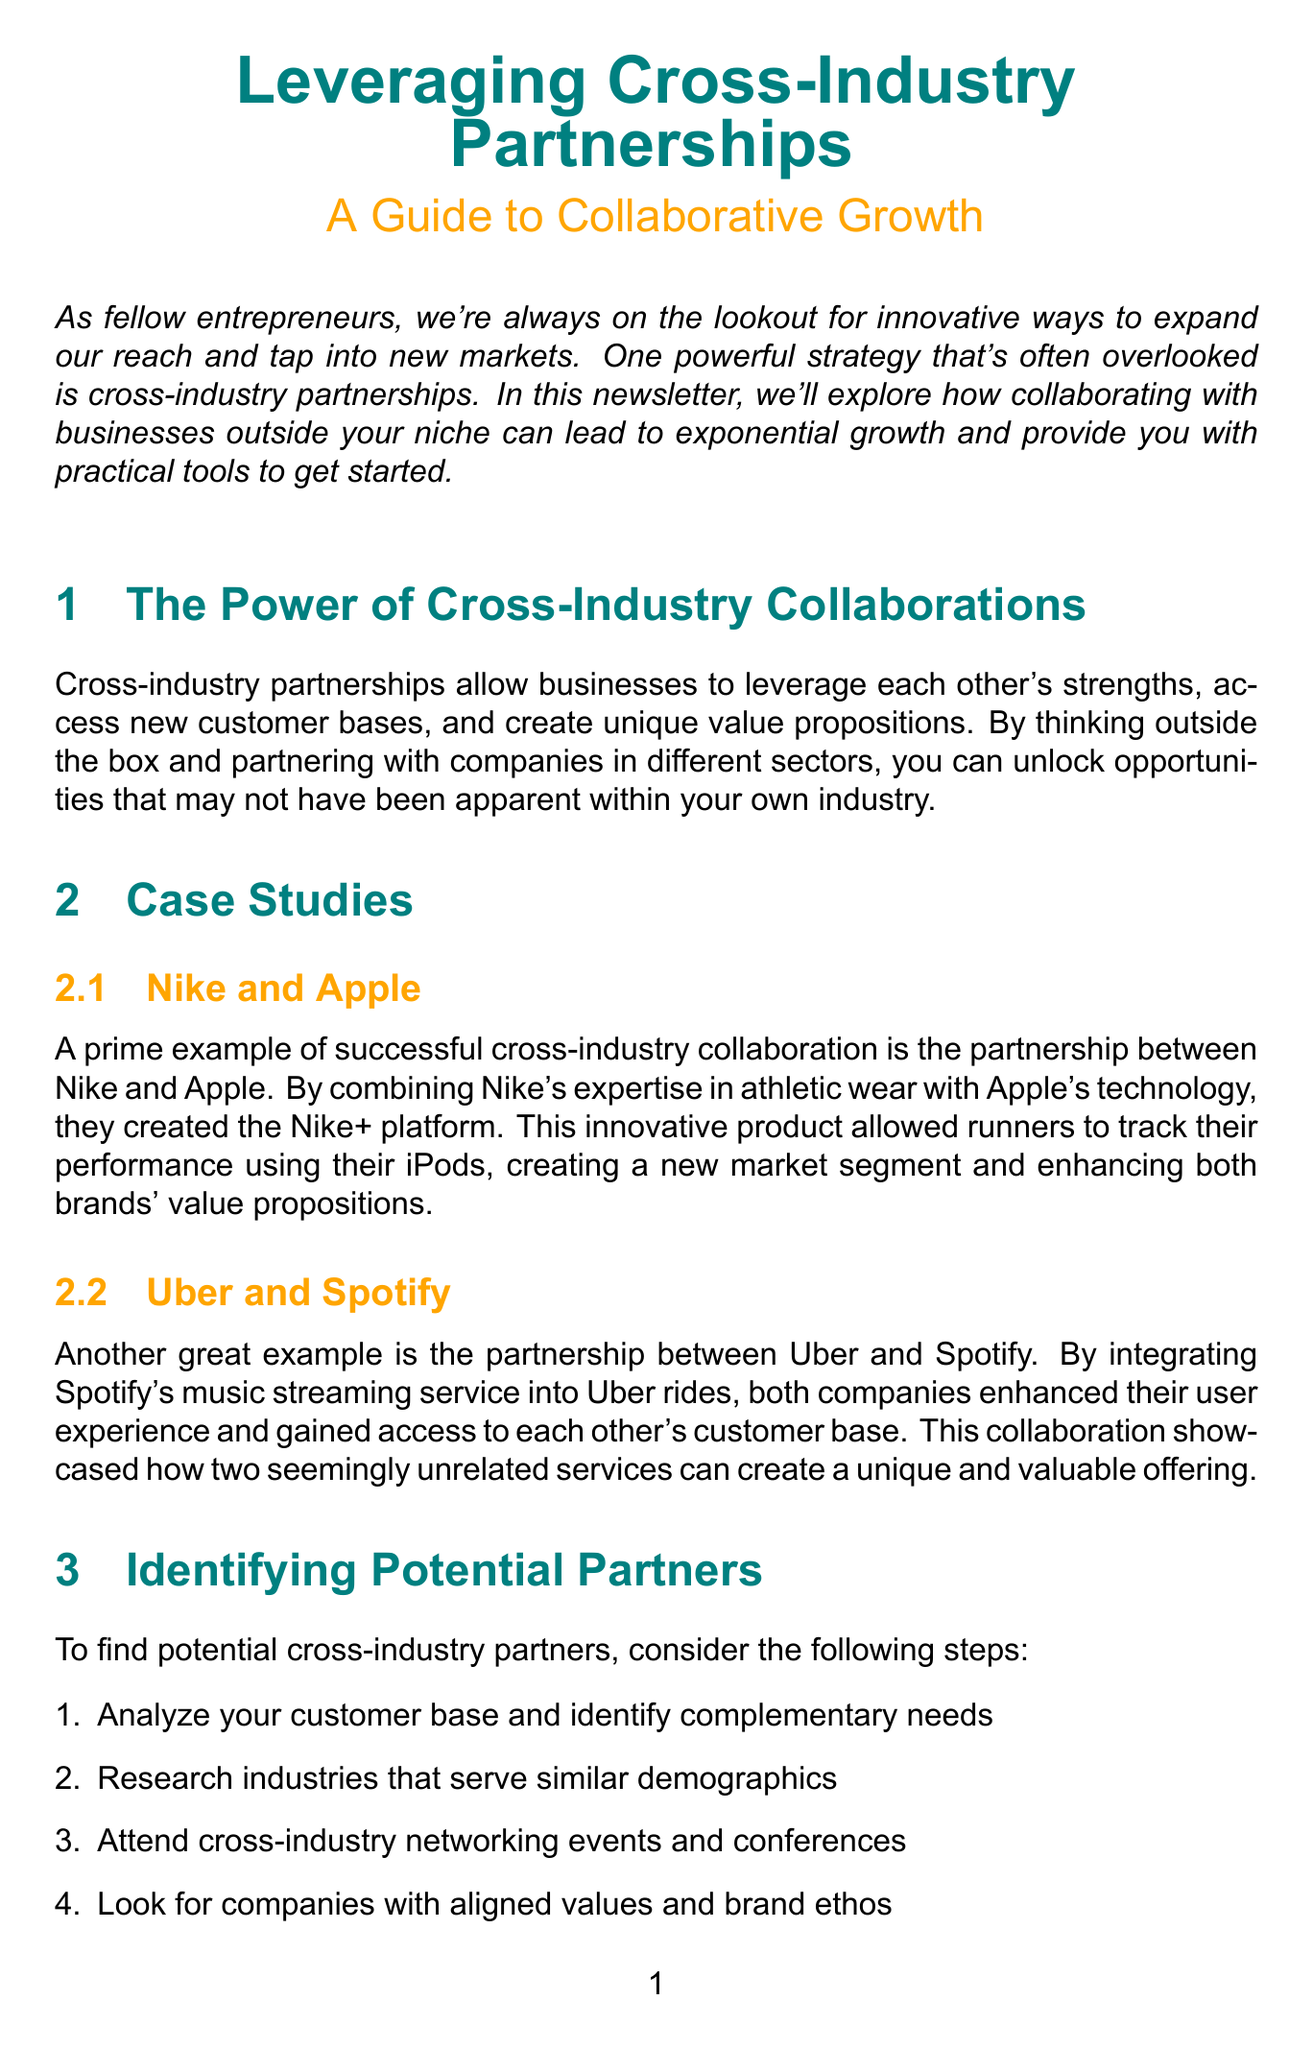What is the title of the newsletter? The title of the newsletter is explicitly stated at the beginning of the document.
Answer: Leveraging Cross-Industry Partnerships: A Guide to Collaborative Growth Who are the featured companies in the case studies? The case studies mention specific companies that collaborated, indicating successful partnerships.
Answer: Nike and Apple, Uber and Spotify What is the first step in identifying potential partners? The document provides a list of steps and indicates the first step in the process.
Answer: Analyze your customer base and identify complementary needs What is a KPI mentioned for measuring success? The document outlines key performance indicators for evaluating partnerships and lists them.
Answer: Customer Acquisition Cost (CAC) What section provides a template for partnership agreements? The document clearly identifies sections that contain templates related to partnerships.
Answer: Partnership Agreement Template What is the main benefit of cross-industry partnerships according to the introduction? The introduction summarizes the advantages of pursuing cross-industry collaborations.
Answer: Exponential growth What should you do before finalizing a partnership agreement? The document advises a specific action to ensure legal safety before finalizing agreements.
Answer: Consult with a legal professional 